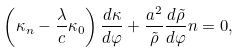<formula> <loc_0><loc_0><loc_500><loc_500>\left ( \kappa _ { n } - \frac { \lambda } { c } \kappa _ { 0 } \right ) \frac { d \kappa } { d \varphi } + \frac { a ^ { 2 } } { \tilde { \rho } } \frac { d \tilde { \rho } } { d \varphi } n = 0 ,</formula> 